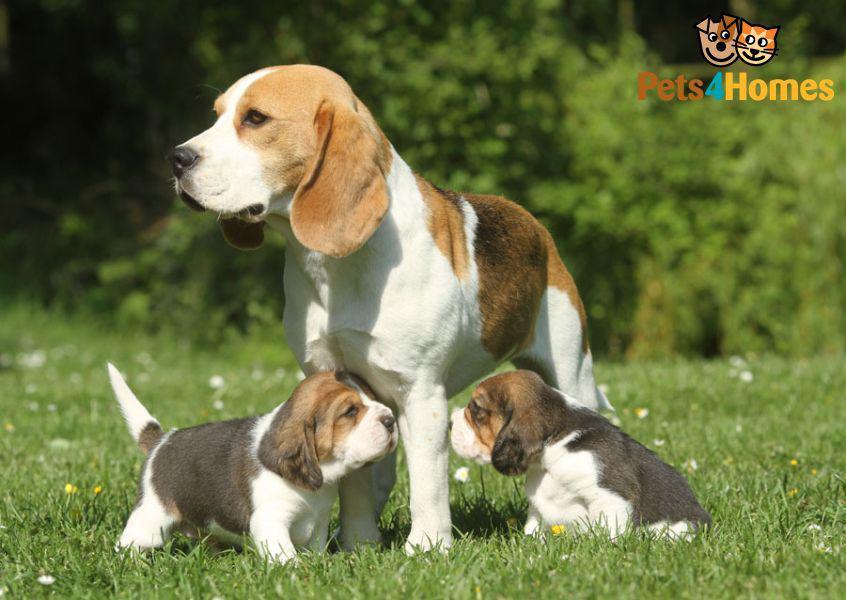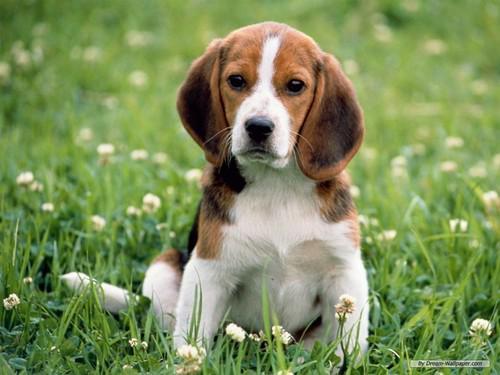The first image is the image on the left, the second image is the image on the right. Analyze the images presented: Is the assertion "In one of the images there is a single beagle standing outside." valid? Answer yes or no. No. 